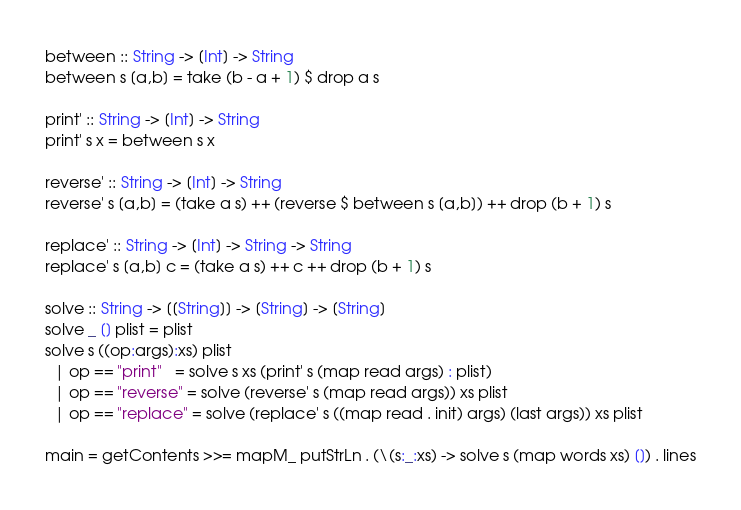Convert code to text. <code><loc_0><loc_0><loc_500><loc_500><_Haskell_>between :: String -> [Int] -> String
between s [a,b] = take (b - a + 1) $ drop a s

print' :: String -> [Int] -> String
print' s x = between s x

reverse' :: String -> [Int] -> String
reverse' s [a,b] = (take a s) ++ (reverse $ between s [a,b]) ++ drop (b + 1) s

replace' :: String -> [Int] -> String -> String
replace' s [a,b] c = (take a s) ++ c ++ drop (b + 1) s

solve :: String -> [[String]] -> [String] -> [String]
solve _ [] plist = plist
solve s ((op:args):xs) plist
  | op == "print"   = solve s xs (print' s (map read args) : plist)
  | op == "reverse" = solve (reverse' s (map read args)) xs plist
  | op == "replace" = solve (replace' s ((map read . init) args) (last args)) xs plist

main = getContents >>= mapM_ putStrLn . (\(s:_:xs) -> solve s (map words xs) []) . lines</code> 